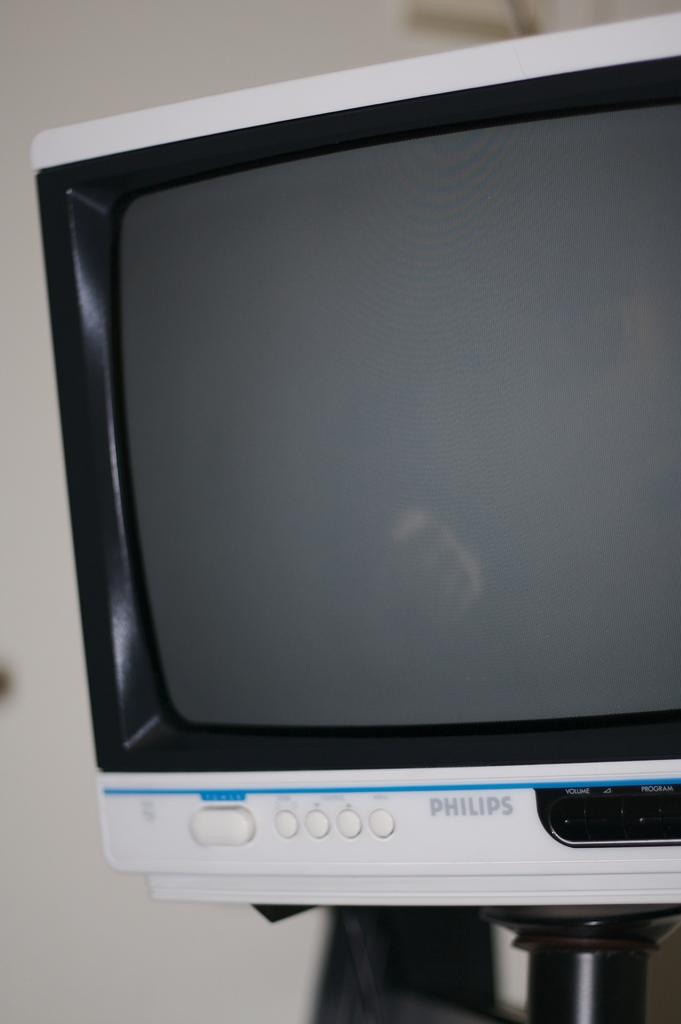<image>
Render a clear and concise summary of the photo. An older Phillips tv or monitor mounted near a wall. 